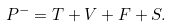<formula> <loc_0><loc_0><loc_500><loc_500>P ^ { - } = T + V + F + S .</formula> 